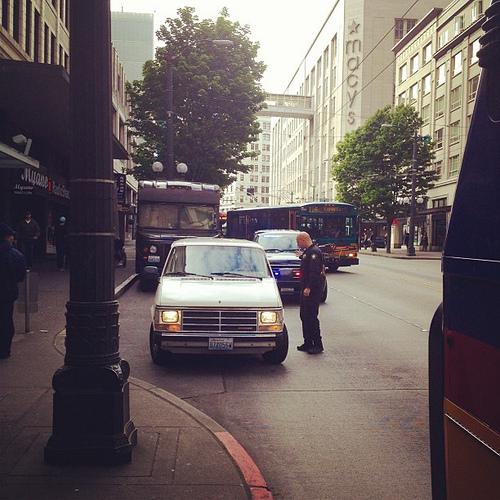Question: how many buses are there?
Choices:
A. Two.
B. Three.
C. One.
D. Four.
Answer with the letter. Answer: C Question: where was the photo taken?
Choices:
A. On the street.
B. On the beach.
C. On the sidewalk.
D. In the forest.
Answer with the letter. Answer: C Question: why is the man talking to the person in the minivan?
Choices:
A. They are friends.
B. He is broken down.
C. The van is out of gas.
D. He pulled him over.
Answer with the letter. Answer: D Question: what is behind the minivan?
Choices:
A. A car.
B. A boat.
C. A UPS truck.
D. A train.
Answer with the letter. Answer: C Question: when was the photo taken?
Choices:
A. At night.
B. At dawn.
C. At dusk.
D. Daytime.
Answer with the letter. Answer: D Question: what color is the UPS van?
Choices:
A. Brown.
B. Yellow.
C. White.
D. Black.
Answer with the letter. Answer: A Question: who is talking to the person in the minivan?
Choices:
A. A fireman.
B. A lawyer.
C. A criminal.
D. A police officer.
Answer with the letter. Answer: D 